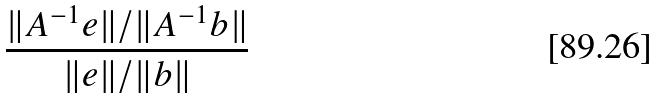Convert formula to latex. <formula><loc_0><loc_0><loc_500><loc_500>\frac { \| A ^ { - 1 } e \| / \| A ^ { - 1 } b \| } { \| e \| / \| b \| }</formula> 